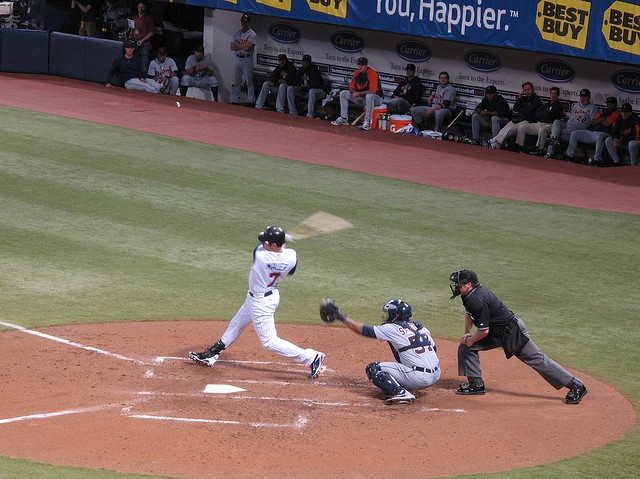Describe the objects in this image and their specific colors. I can see people in black, gray, salmon, and darkgray tones, people in black, lavender, and darkgray tones, people in black, lavender, gray, and darkgray tones, people in black, gray, brown, and maroon tones, and people in black, gray, and maroon tones in this image. 